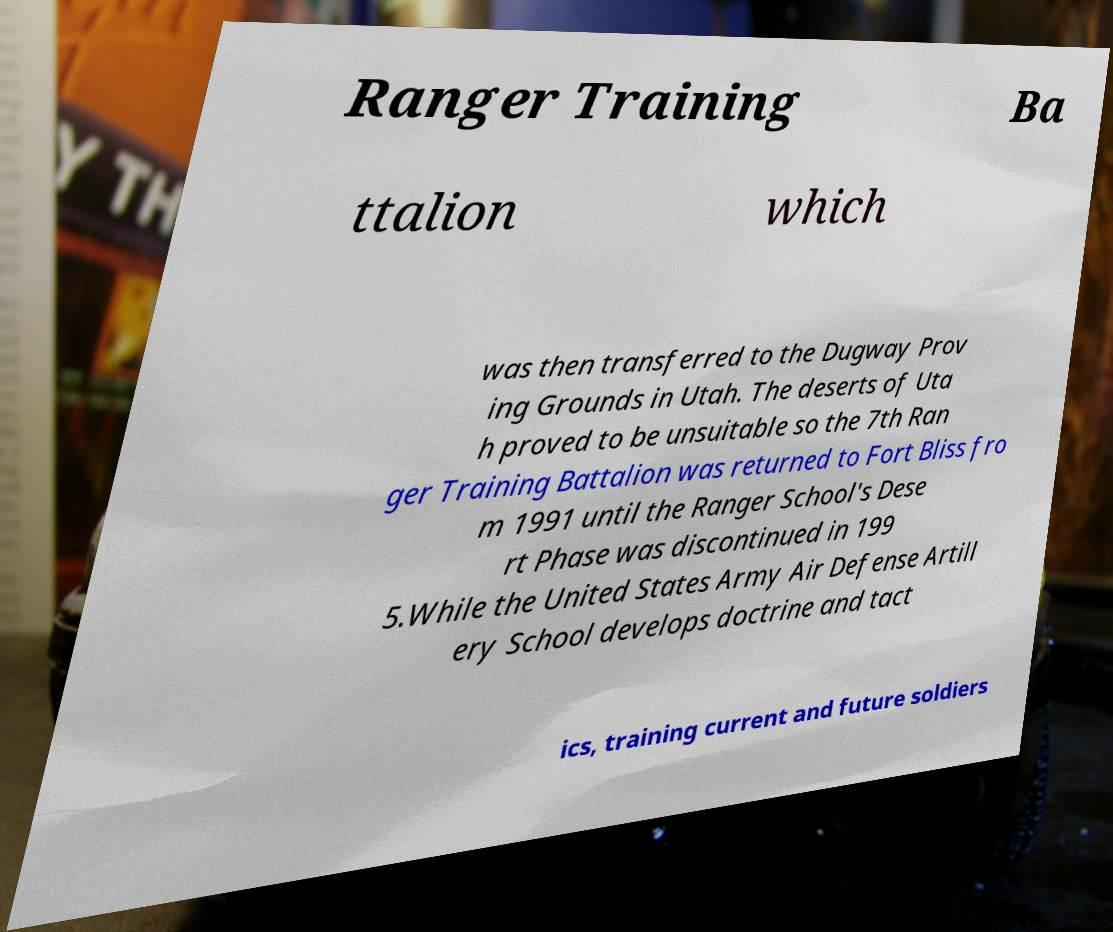What messages or text are displayed in this image? I need them in a readable, typed format. Ranger Training Ba ttalion which was then transferred to the Dugway Prov ing Grounds in Utah. The deserts of Uta h proved to be unsuitable so the 7th Ran ger Training Battalion was returned to Fort Bliss fro m 1991 until the Ranger School's Dese rt Phase was discontinued in 199 5.While the United States Army Air Defense Artill ery School develops doctrine and tact ics, training current and future soldiers 